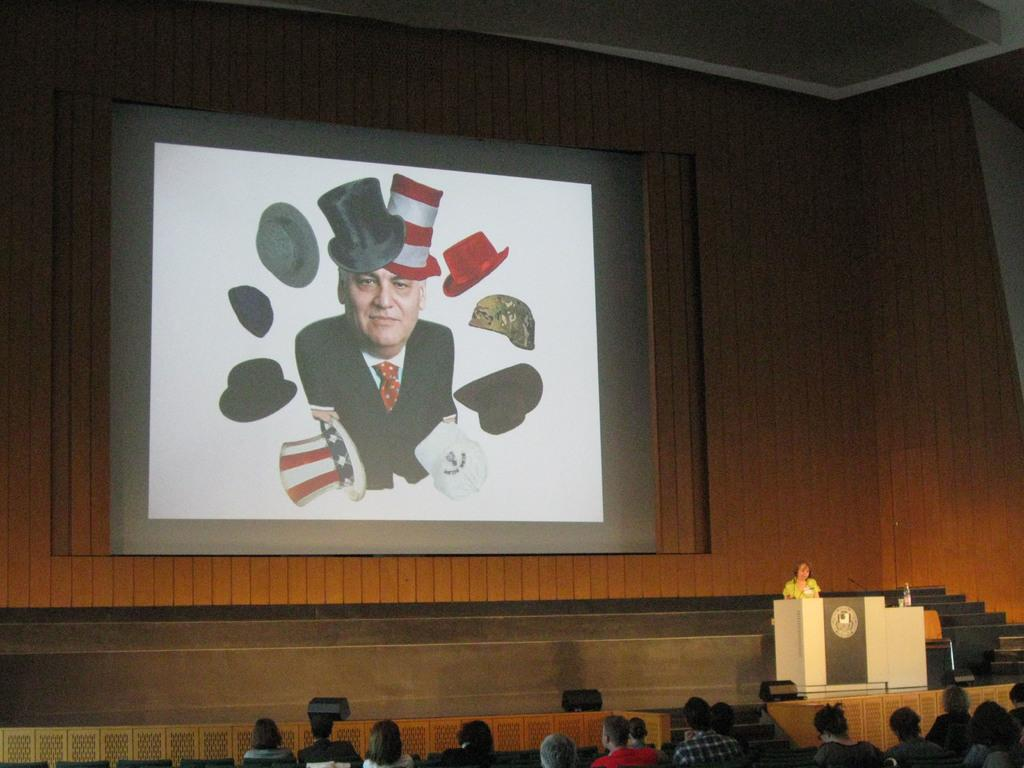What are the people in the image doing? The people in the image are sitting on chairs. What can be seen in the background of the image? There is a stage, a woman standing near a podium, a wall, and a screen on the wall in the background of the image. Where is the faucet located in the image? There is no faucet present in the image. How many people are crying in the image? There is no indication of anyone crying in the image. 